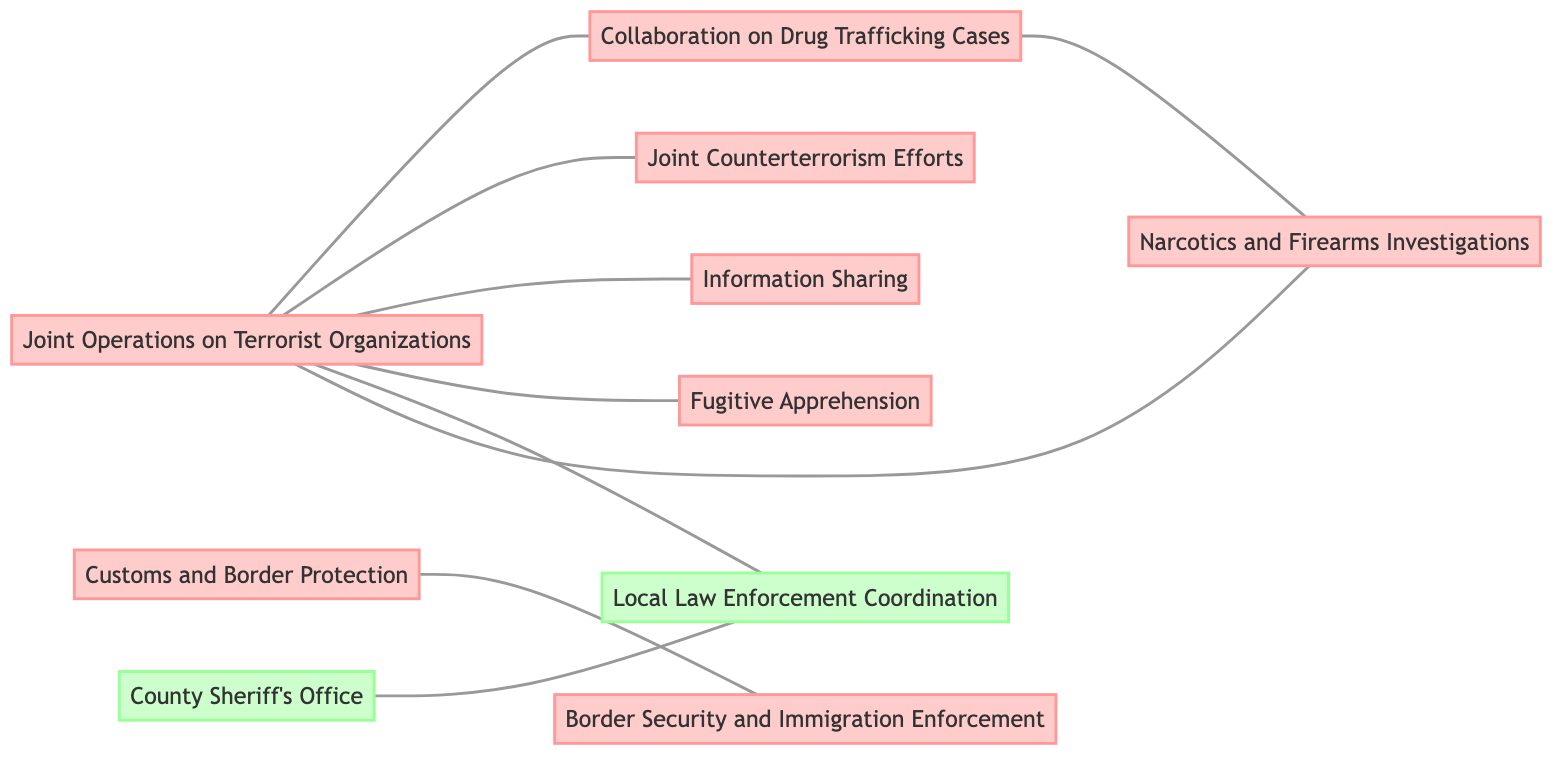What is the total number of law enforcement agencies shown in the diagram? The diagram lists ten nodes representing law enforcement agencies: FBI, DEA, ATF, CIA, NSA, USMS, CBP, ICE, Local Police Departments, and County Sheriff's Office. Counting all these nodes gives a total of 10 agencies.
Answer: 10 Which agency collaborates with the DEA on narcotics and firearms investigations? The edge connecting DEA and ATF indicates that they collaborate on narcotics and firearms investigations, as described by the label on the edge.
Answer: ATF How many collaborations does the FBI have with other agencies represented in the diagram? Upon examining the edges linked to the FBI, there are five collaborations: with DEA, CIA, NSA, USMS, and LocalPD. Counting these collaborations results in a total of 5.
Answer: 5 What relationship exists between Customs and Border Protection and Immigration and Customs Enforcement? The diagram shows an edge between CBP and ICE labeled “Border Security and Immigration Enforcement,” indicating that their relationship focuses on these particular areas of law enforcement.
Answer: Border Security and Immigration Enforcement Which law enforcement agency has a coordination relationship with Local Police Departments? The diagram specifies that the Sheriff has a direct coordination relationship with Local Police Departments as indicated by the edge connecting them, labeled “Local Law Enforcement Coordination.”
Answer: County Sheriff's Office Which agency primarily works with the FBI for fugitive apprehension? The edge labeled “Fugitive Apprehension” connects the FBI to the United States Marshals Service, indicating that USMS works primarily with the FBI in this context.
Answer: United States Marshals Service How many edges are connected to the FBI? By reviewing the edges connected to the FBI, we see links to DEA, CIA, NSA, USMS, and LocalPD, making a total of five edges connected to the FBI.
Answer: 5 Which two agencies collaborate specifically on drug trafficking cases? The edge between FBI and DEA is labeled “Collaboration on Drug Trafficking Cases,” indicating that these two agencies specifically collaborate in this area of law enforcement.
Answer: Drug Enforcement Administration What type of information sharing occurs between the FBI and the NSA? According to the edge connecting FBI and NSA, the relationship involves “Information Sharing,” suggesting collaboration between these agencies regarding information exchange.
Answer: Information Sharing 